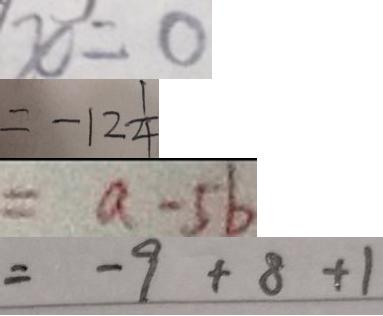<formula> <loc_0><loc_0><loc_500><loc_500>x = 0 
 = - 1 2 \frac { 1 } { 4 } 
 = a - 5 b 
 = - 9 + 8 + 1</formula> 